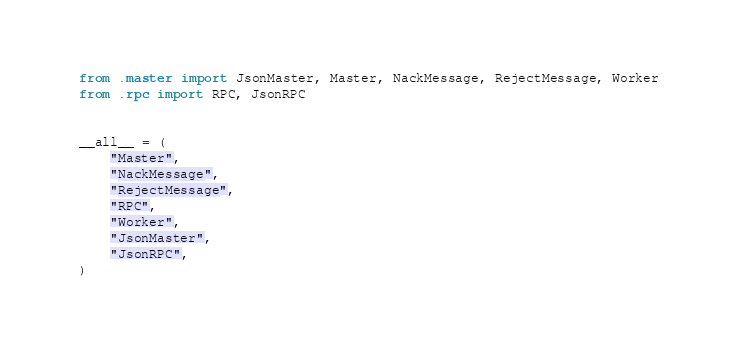Convert code to text. <code><loc_0><loc_0><loc_500><loc_500><_Python_>from .master import JsonMaster, Master, NackMessage, RejectMessage, Worker
from .rpc import RPC, JsonRPC


__all__ = (
    "Master",
    "NackMessage",
    "RejectMessage",
    "RPC",
    "Worker",
    "JsonMaster",
    "JsonRPC",
)
</code> 